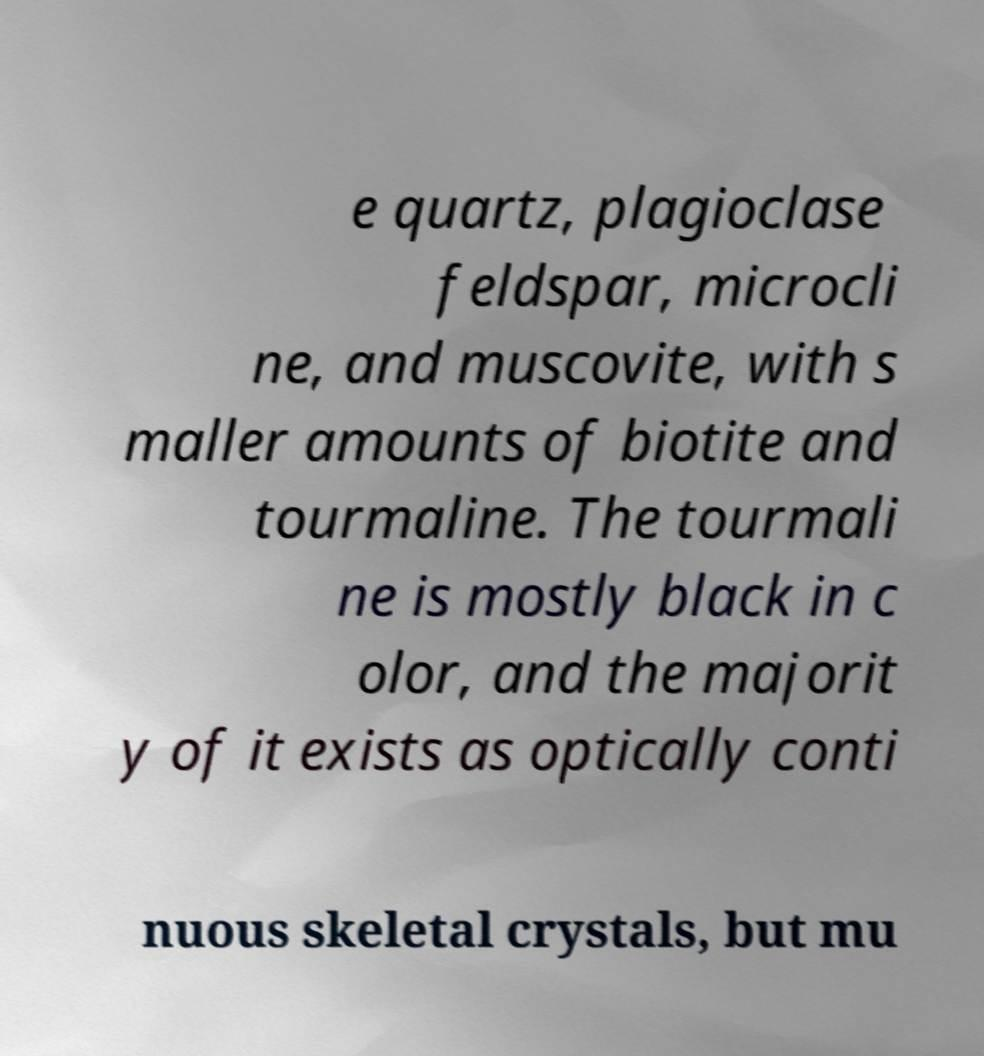Please identify and transcribe the text found in this image. e quartz, plagioclase feldspar, microcli ne, and muscovite, with s maller amounts of biotite and tourmaline. The tourmali ne is mostly black in c olor, and the majorit y of it exists as optically conti nuous skeletal crystals, but mu 